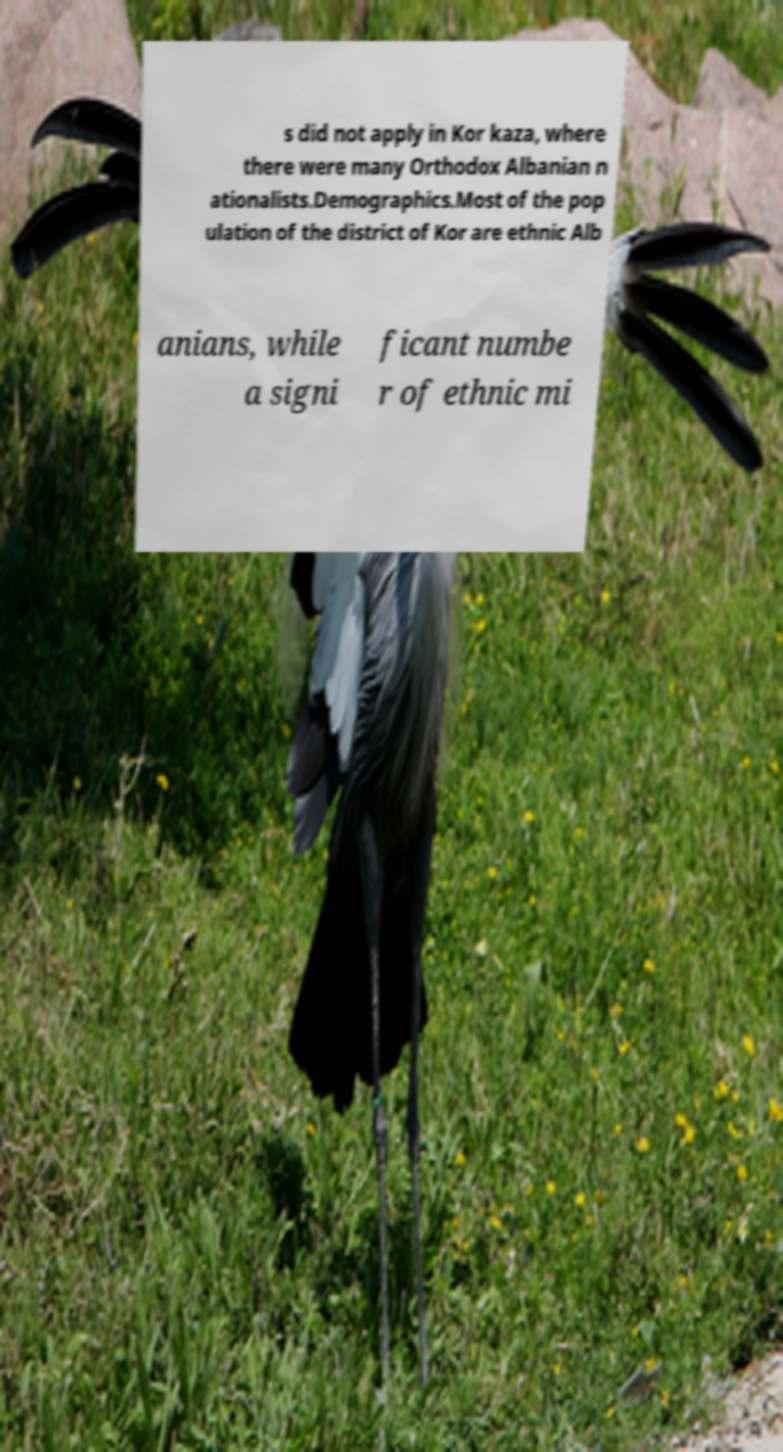Can you accurately transcribe the text from the provided image for me? s did not apply in Kor kaza, where there were many Orthodox Albanian n ationalists.Demographics.Most of the pop ulation of the district of Kor are ethnic Alb anians, while a signi ficant numbe r of ethnic mi 